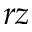Convert formula to latex. <formula><loc_0><loc_0><loc_500><loc_500>r z</formula> 